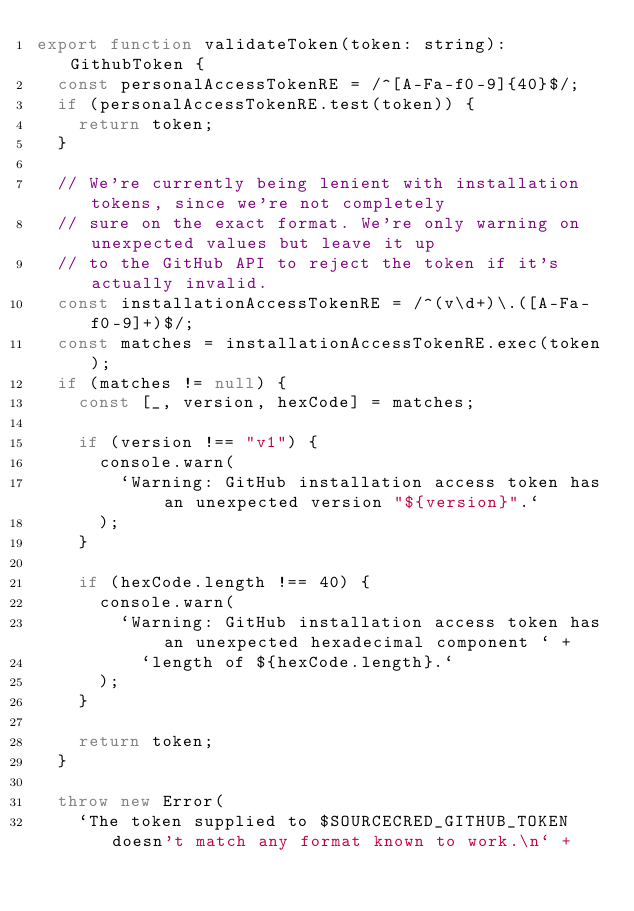<code> <loc_0><loc_0><loc_500><loc_500><_JavaScript_>export function validateToken(token: string): GithubToken {
  const personalAccessTokenRE = /^[A-Fa-f0-9]{40}$/;
  if (personalAccessTokenRE.test(token)) {
    return token;
  }

  // We're currently being lenient with installation tokens, since we're not completely
  // sure on the exact format. We're only warning on unexpected values but leave it up
  // to the GitHub API to reject the token if it's actually invalid.
  const installationAccessTokenRE = /^(v\d+)\.([A-Fa-f0-9]+)$/;
  const matches = installationAccessTokenRE.exec(token);
  if (matches != null) {
    const [_, version, hexCode] = matches;

    if (version !== "v1") {
      console.warn(
        `Warning: GitHub installation access token has an unexpected version "${version}".`
      );
    }

    if (hexCode.length !== 40) {
      console.warn(
        `Warning: GitHub installation access token has an unexpected hexadecimal component ` +
          `length of ${hexCode.length}.`
      );
    }

    return token;
  }

  throw new Error(
    `The token supplied to $SOURCECRED_GITHUB_TOKEN doesn't match any format known to work.\n` +</code> 